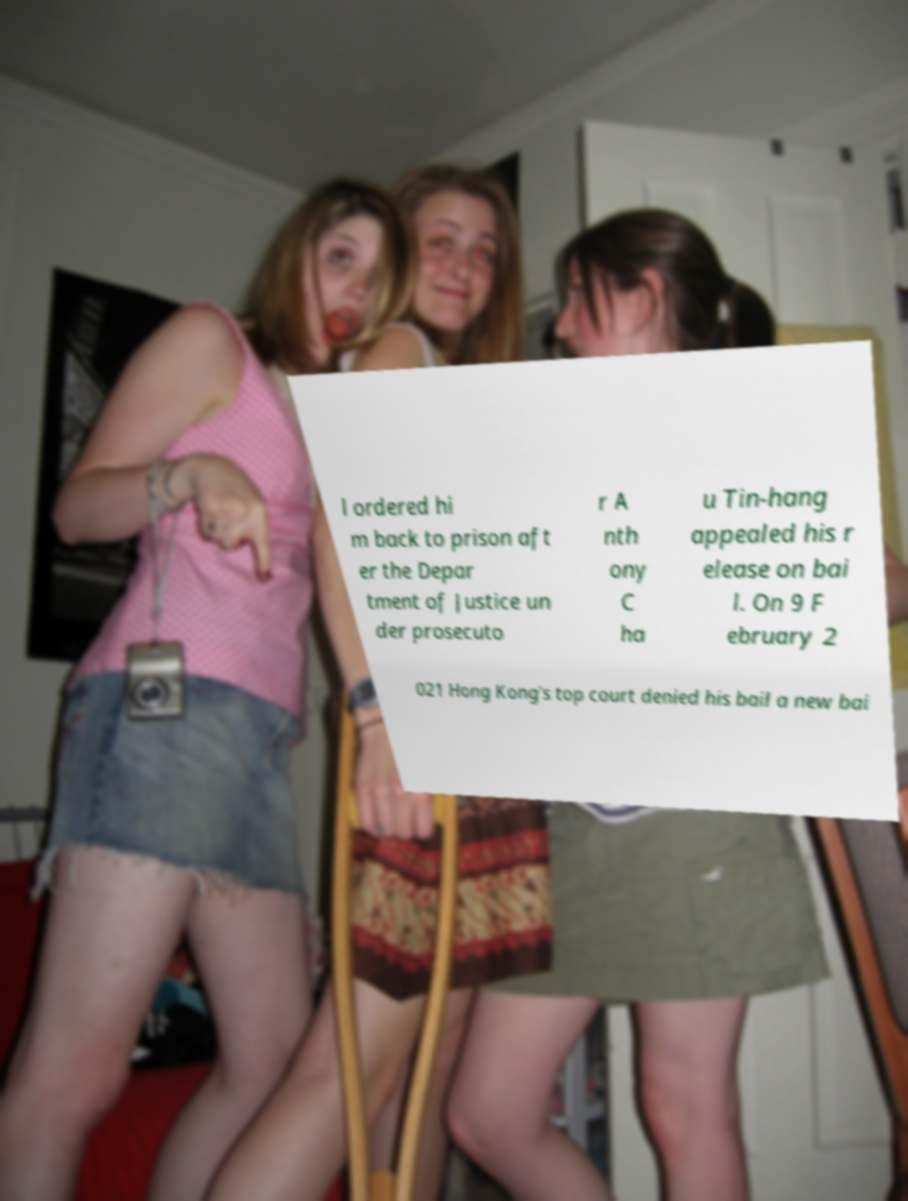Can you accurately transcribe the text from the provided image for me? l ordered hi m back to prison aft er the Depar tment of Justice un der prosecuto r A nth ony C ha u Tin-hang appealed his r elease on bai l. On 9 F ebruary 2 021 Hong Kong's top court denied his bail a new bai 